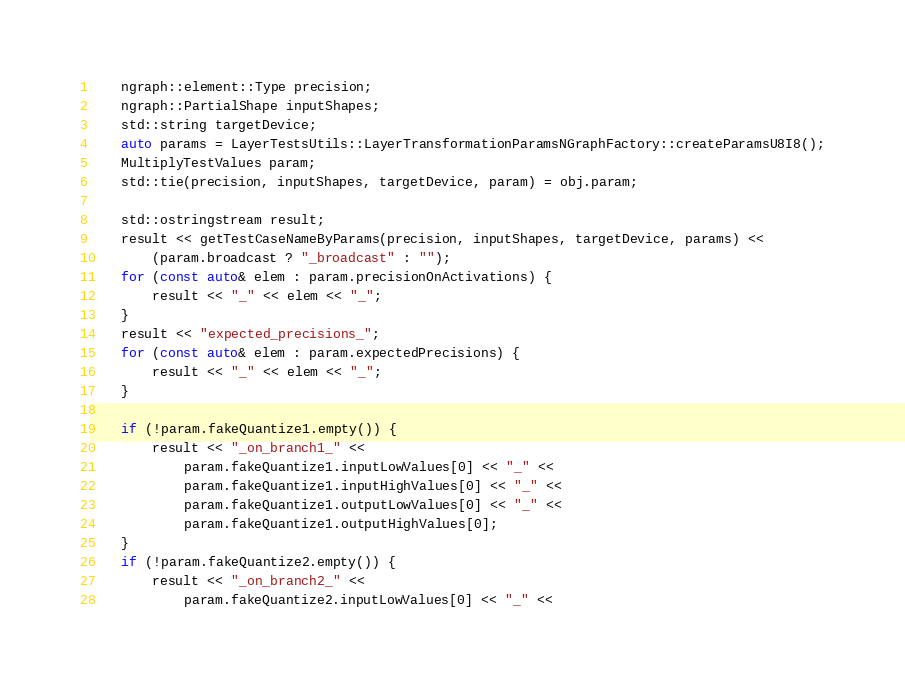Convert code to text. <code><loc_0><loc_0><loc_500><loc_500><_C++_>    ngraph::element::Type precision;
    ngraph::PartialShape inputShapes;
    std::string targetDevice;
    auto params = LayerTestsUtils::LayerTransformationParamsNGraphFactory::createParamsU8I8();
    MultiplyTestValues param;
    std::tie(precision, inputShapes, targetDevice, param) = obj.param;

    std::ostringstream result;
    result << getTestCaseNameByParams(precision, inputShapes, targetDevice, params) <<
        (param.broadcast ? "_broadcast" : "");
    for (const auto& elem : param.precisionOnActivations) {
        result << "_" << elem << "_";
    }
    result << "expected_precisions_";
    for (const auto& elem : param.expectedPrecisions) {
        result << "_" << elem << "_";
    }

    if (!param.fakeQuantize1.empty()) {
        result << "_on_branch1_" <<
            param.fakeQuantize1.inputLowValues[0] << "_" <<
            param.fakeQuantize1.inputHighValues[0] << "_" <<
            param.fakeQuantize1.outputLowValues[0] << "_" <<
            param.fakeQuantize1.outputHighValues[0];
    }
    if (!param.fakeQuantize2.empty()) {
        result << "_on_branch2_" <<
            param.fakeQuantize2.inputLowValues[0] << "_" <<</code> 